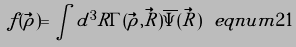<formula> <loc_0><loc_0><loc_500><loc_500>f ( \vec { \rho } ) = \int d ^ { 3 } R \Gamma ( \vec { \rho } , \vec { R } ) \overline { \Psi } ( \vec { R } ) \ e q n u m { 2 1 }</formula> 